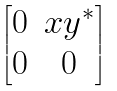<formula> <loc_0><loc_0><loc_500><loc_500>\begin{bmatrix} 0 & x y ^ { * } \\ 0 & 0 \end{bmatrix}</formula> 